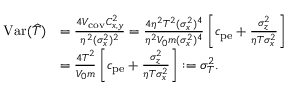<formula> <loc_0><loc_0><loc_500><loc_500>\begin{array} { r l } { V a r ( \widehat { T } ) } & { = \frac { 4 V _ { c o v } C _ { x , y } ^ { 2 } } { \eta ^ { 2 } ( \sigma _ { x } ^ { 2 } ) ^ { 2 } } = \frac { 4 \eta ^ { 2 } T ^ { 2 } ( \sigma _ { x } ^ { 2 } ) ^ { 4 } } { \eta ^ { 2 } V _ { 0 } m ( \sigma _ { x } ^ { 2 } ) ^ { 4 } } \left [ c _ { p e } + \frac { \sigma _ { z } ^ { 2 } } { \eta T \sigma _ { x } ^ { 2 } } \right ] } \\ & { = \frac { 4 T ^ { 2 } } { V _ { 0 } m } \left [ c _ { p e } + \frac { \sigma _ { z } ^ { 2 } } { \eta T \sigma _ { x } ^ { 2 } } \right ] \colon = \sigma _ { T } ^ { 2 } . } \end{array}</formula> 